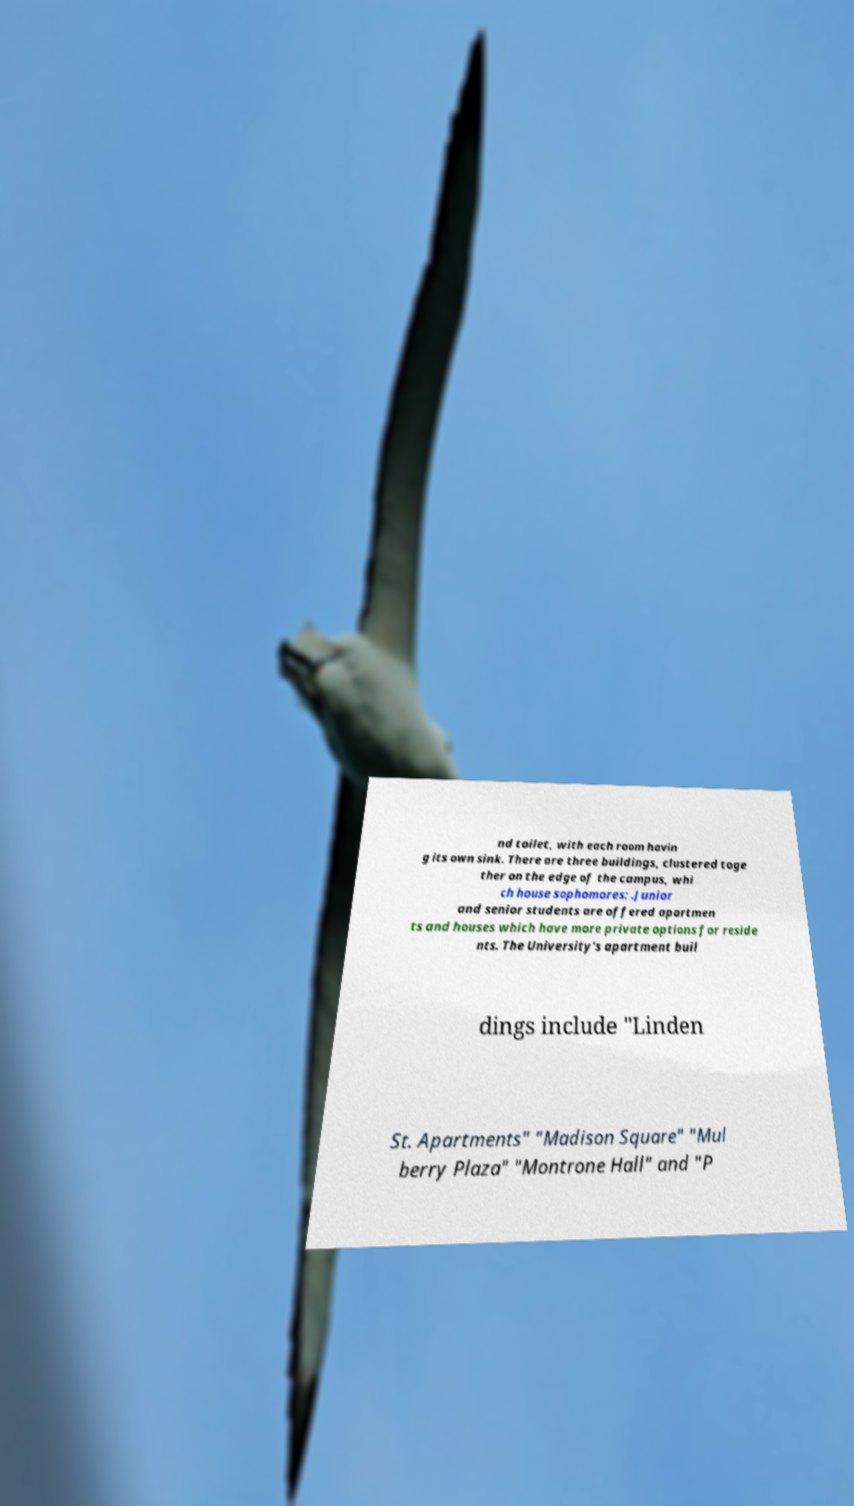Please read and relay the text visible in this image. What does it say? nd toilet, with each room havin g its own sink. There are three buildings, clustered toge ther on the edge of the campus, whi ch house sophomores: .Junior and senior students are offered apartmen ts and houses which have more private options for reside nts. The University's apartment buil dings include "Linden St. Apartments" "Madison Square" "Mul berry Plaza" "Montrone Hall" and "P 